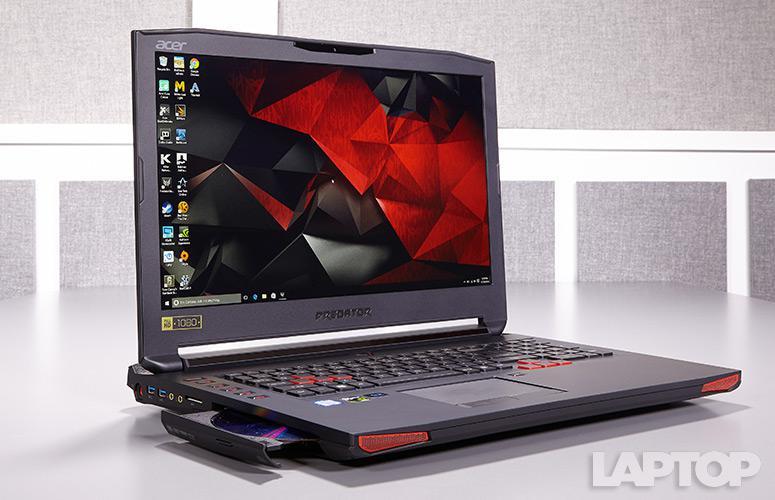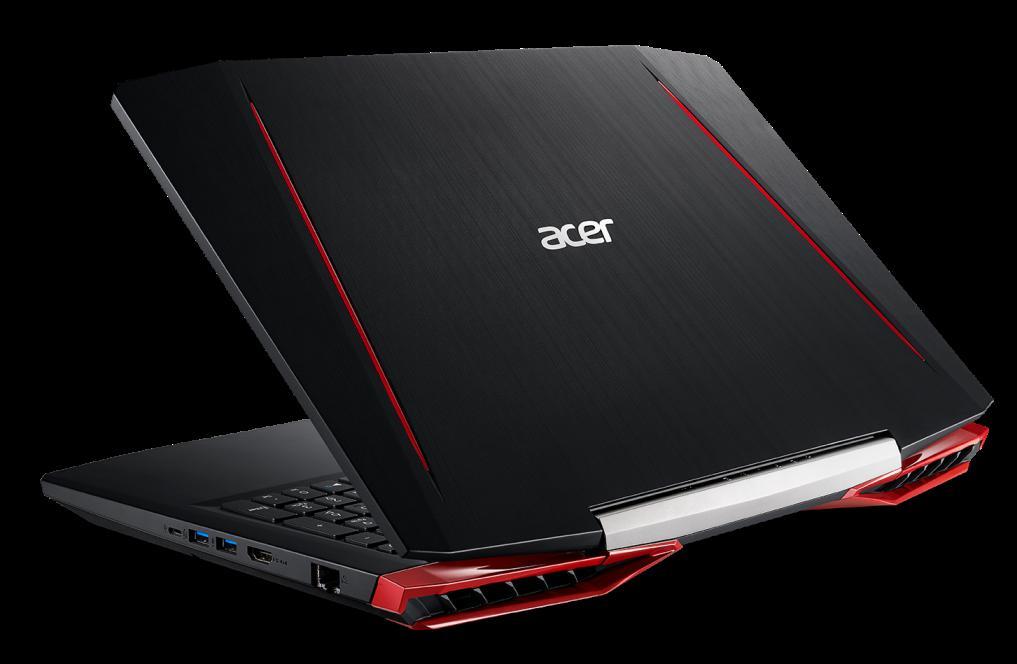The first image is the image on the left, the second image is the image on the right. For the images shown, is this caption "The laptop on the left is opened to at least 90-degrees and has its screen facing somewhat forward, and the laptop on the right is open to about 45-degrees or less and has its back to the camera." true? Answer yes or no. Yes. 